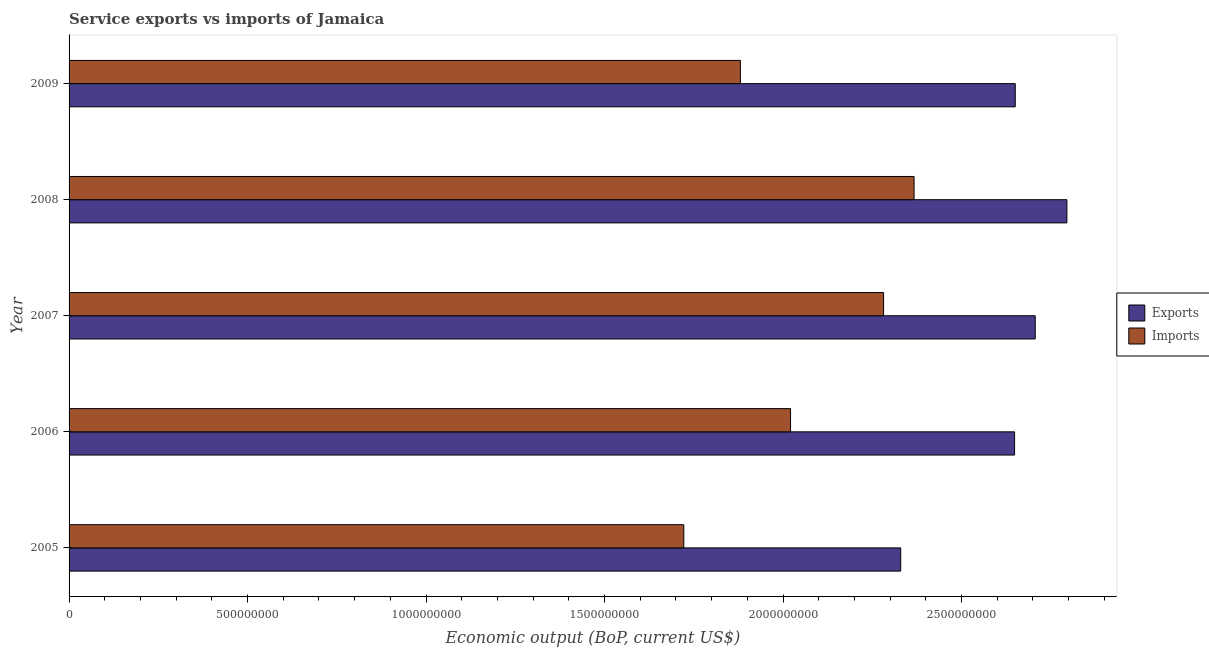How many different coloured bars are there?
Your answer should be compact. 2. Are the number of bars per tick equal to the number of legend labels?
Your answer should be compact. Yes. How many bars are there on the 4th tick from the bottom?
Keep it short and to the point. 2. What is the amount of service exports in 2008?
Provide a short and direct response. 2.80e+09. Across all years, what is the maximum amount of service exports?
Ensure brevity in your answer.  2.80e+09. Across all years, what is the minimum amount of service exports?
Your answer should be compact. 2.33e+09. What is the total amount of service imports in the graph?
Your response must be concise. 1.03e+1. What is the difference between the amount of service imports in 2006 and that in 2009?
Your answer should be very brief. 1.40e+08. What is the difference between the amount of service imports in 2008 and the amount of service exports in 2007?
Keep it short and to the point. -3.39e+08. What is the average amount of service imports per year?
Give a very brief answer. 2.05e+09. In the year 2005, what is the difference between the amount of service exports and amount of service imports?
Provide a succinct answer. 6.08e+08. In how many years, is the amount of service imports greater than 800000000 US$?
Your answer should be very brief. 5. What is the ratio of the amount of service imports in 2006 to that in 2007?
Offer a very short reply. 0.89. Is the difference between the amount of service imports in 2005 and 2008 greater than the difference between the amount of service exports in 2005 and 2008?
Make the answer very short. No. What is the difference between the highest and the second highest amount of service imports?
Ensure brevity in your answer.  8.54e+07. What is the difference between the highest and the lowest amount of service exports?
Offer a terse response. 4.66e+08. What does the 1st bar from the top in 2008 represents?
Make the answer very short. Imports. What does the 2nd bar from the bottom in 2009 represents?
Your answer should be very brief. Imports. How many bars are there?
Offer a terse response. 10. What is the difference between two consecutive major ticks on the X-axis?
Make the answer very short. 5.00e+08. Does the graph contain grids?
Make the answer very short. No. Where does the legend appear in the graph?
Give a very brief answer. Center right. How are the legend labels stacked?
Make the answer very short. Vertical. What is the title of the graph?
Provide a succinct answer. Service exports vs imports of Jamaica. Does "Number of departures" appear as one of the legend labels in the graph?
Provide a short and direct response. No. What is the label or title of the X-axis?
Provide a succinct answer. Economic output (BoP, current US$). What is the label or title of the Y-axis?
Ensure brevity in your answer.  Year. What is the Economic output (BoP, current US$) of Exports in 2005?
Offer a very short reply. 2.33e+09. What is the Economic output (BoP, current US$) in Imports in 2005?
Make the answer very short. 1.72e+09. What is the Economic output (BoP, current US$) of Exports in 2006?
Your response must be concise. 2.65e+09. What is the Economic output (BoP, current US$) of Imports in 2006?
Offer a very short reply. 2.02e+09. What is the Economic output (BoP, current US$) of Exports in 2007?
Provide a succinct answer. 2.71e+09. What is the Economic output (BoP, current US$) of Imports in 2007?
Give a very brief answer. 2.28e+09. What is the Economic output (BoP, current US$) of Exports in 2008?
Provide a succinct answer. 2.80e+09. What is the Economic output (BoP, current US$) in Imports in 2008?
Your answer should be very brief. 2.37e+09. What is the Economic output (BoP, current US$) in Exports in 2009?
Your answer should be very brief. 2.65e+09. What is the Economic output (BoP, current US$) of Imports in 2009?
Provide a short and direct response. 1.88e+09. Across all years, what is the maximum Economic output (BoP, current US$) of Exports?
Provide a short and direct response. 2.80e+09. Across all years, what is the maximum Economic output (BoP, current US$) of Imports?
Offer a terse response. 2.37e+09. Across all years, what is the minimum Economic output (BoP, current US$) in Exports?
Make the answer very short. 2.33e+09. Across all years, what is the minimum Economic output (BoP, current US$) in Imports?
Your answer should be very brief. 1.72e+09. What is the total Economic output (BoP, current US$) of Exports in the graph?
Provide a succinct answer. 1.31e+1. What is the total Economic output (BoP, current US$) in Imports in the graph?
Offer a very short reply. 1.03e+1. What is the difference between the Economic output (BoP, current US$) in Exports in 2005 and that in 2006?
Provide a succinct answer. -3.19e+08. What is the difference between the Economic output (BoP, current US$) in Imports in 2005 and that in 2006?
Your answer should be compact. -2.99e+08. What is the difference between the Economic output (BoP, current US$) in Exports in 2005 and that in 2007?
Your answer should be compact. -3.77e+08. What is the difference between the Economic output (BoP, current US$) of Imports in 2005 and that in 2007?
Ensure brevity in your answer.  -5.60e+08. What is the difference between the Economic output (BoP, current US$) of Exports in 2005 and that in 2008?
Provide a succinct answer. -4.66e+08. What is the difference between the Economic output (BoP, current US$) of Imports in 2005 and that in 2008?
Ensure brevity in your answer.  -6.45e+08. What is the difference between the Economic output (BoP, current US$) in Exports in 2005 and that in 2009?
Ensure brevity in your answer.  -3.21e+08. What is the difference between the Economic output (BoP, current US$) in Imports in 2005 and that in 2009?
Make the answer very short. -1.59e+08. What is the difference between the Economic output (BoP, current US$) of Exports in 2006 and that in 2007?
Offer a terse response. -5.79e+07. What is the difference between the Economic output (BoP, current US$) of Imports in 2006 and that in 2007?
Ensure brevity in your answer.  -2.61e+08. What is the difference between the Economic output (BoP, current US$) of Exports in 2006 and that in 2008?
Your answer should be compact. -1.47e+08. What is the difference between the Economic output (BoP, current US$) in Imports in 2006 and that in 2008?
Keep it short and to the point. -3.46e+08. What is the difference between the Economic output (BoP, current US$) in Exports in 2006 and that in 2009?
Offer a very short reply. -1.88e+06. What is the difference between the Economic output (BoP, current US$) of Imports in 2006 and that in 2009?
Your answer should be compact. 1.40e+08. What is the difference between the Economic output (BoP, current US$) of Exports in 2007 and that in 2008?
Give a very brief answer. -8.87e+07. What is the difference between the Economic output (BoP, current US$) in Imports in 2007 and that in 2008?
Provide a succinct answer. -8.54e+07. What is the difference between the Economic output (BoP, current US$) of Exports in 2007 and that in 2009?
Offer a terse response. 5.60e+07. What is the difference between the Economic output (BoP, current US$) of Imports in 2007 and that in 2009?
Provide a short and direct response. 4.01e+08. What is the difference between the Economic output (BoP, current US$) in Exports in 2008 and that in 2009?
Offer a terse response. 1.45e+08. What is the difference between the Economic output (BoP, current US$) in Imports in 2008 and that in 2009?
Keep it short and to the point. 4.86e+08. What is the difference between the Economic output (BoP, current US$) in Exports in 2005 and the Economic output (BoP, current US$) in Imports in 2006?
Your response must be concise. 3.09e+08. What is the difference between the Economic output (BoP, current US$) in Exports in 2005 and the Economic output (BoP, current US$) in Imports in 2007?
Offer a terse response. 4.80e+07. What is the difference between the Economic output (BoP, current US$) of Exports in 2005 and the Economic output (BoP, current US$) of Imports in 2008?
Your answer should be very brief. -3.74e+07. What is the difference between the Economic output (BoP, current US$) in Exports in 2005 and the Economic output (BoP, current US$) in Imports in 2009?
Offer a very short reply. 4.49e+08. What is the difference between the Economic output (BoP, current US$) in Exports in 2006 and the Economic output (BoP, current US$) in Imports in 2007?
Provide a succinct answer. 3.67e+08. What is the difference between the Economic output (BoP, current US$) of Exports in 2006 and the Economic output (BoP, current US$) of Imports in 2008?
Provide a short and direct response. 2.82e+08. What is the difference between the Economic output (BoP, current US$) of Exports in 2006 and the Economic output (BoP, current US$) of Imports in 2009?
Your answer should be compact. 7.68e+08. What is the difference between the Economic output (BoP, current US$) of Exports in 2007 and the Economic output (BoP, current US$) of Imports in 2008?
Provide a short and direct response. 3.39e+08. What is the difference between the Economic output (BoP, current US$) of Exports in 2007 and the Economic output (BoP, current US$) of Imports in 2009?
Ensure brevity in your answer.  8.26e+08. What is the difference between the Economic output (BoP, current US$) in Exports in 2008 and the Economic output (BoP, current US$) in Imports in 2009?
Give a very brief answer. 9.15e+08. What is the average Economic output (BoP, current US$) in Exports per year?
Give a very brief answer. 2.63e+09. What is the average Economic output (BoP, current US$) of Imports per year?
Provide a succinct answer. 2.05e+09. In the year 2005, what is the difference between the Economic output (BoP, current US$) in Exports and Economic output (BoP, current US$) in Imports?
Keep it short and to the point. 6.08e+08. In the year 2006, what is the difference between the Economic output (BoP, current US$) in Exports and Economic output (BoP, current US$) in Imports?
Keep it short and to the point. 6.28e+08. In the year 2007, what is the difference between the Economic output (BoP, current US$) in Exports and Economic output (BoP, current US$) in Imports?
Ensure brevity in your answer.  4.25e+08. In the year 2008, what is the difference between the Economic output (BoP, current US$) in Exports and Economic output (BoP, current US$) in Imports?
Give a very brief answer. 4.28e+08. In the year 2009, what is the difference between the Economic output (BoP, current US$) in Exports and Economic output (BoP, current US$) in Imports?
Offer a very short reply. 7.70e+08. What is the ratio of the Economic output (BoP, current US$) of Exports in 2005 to that in 2006?
Your response must be concise. 0.88. What is the ratio of the Economic output (BoP, current US$) in Imports in 2005 to that in 2006?
Provide a succinct answer. 0.85. What is the ratio of the Economic output (BoP, current US$) in Exports in 2005 to that in 2007?
Make the answer very short. 0.86. What is the ratio of the Economic output (BoP, current US$) in Imports in 2005 to that in 2007?
Your response must be concise. 0.75. What is the ratio of the Economic output (BoP, current US$) in Exports in 2005 to that in 2008?
Give a very brief answer. 0.83. What is the ratio of the Economic output (BoP, current US$) in Imports in 2005 to that in 2008?
Provide a succinct answer. 0.73. What is the ratio of the Economic output (BoP, current US$) in Exports in 2005 to that in 2009?
Provide a short and direct response. 0.88. What is the ratio of the Economic output (BoP, current US$) of Imports in 2005 to that in 2009?
Give a very brief answer. 0.92. What is the ratio of the Economic output (BoP, current US$) of Exports in 2006 to that in 2007?
Your answer should be compact. 0.98. What is the ratio of the Economic output (BoP, current US$) of Imports in 2006 to that in 2007?
Provide a succinct answer. 0.89. What is the ratio of the Economic output (BoP, current US$) in Exports in 2006 to that in 2008?
Give a very brief answer. 0.95. What is the ratio of the Economic output (BoP, current US$) in Imports in 2006 to that in 2008?
Your answer should be very brief. 0.85. What is the ratio of the Economic output (BoP, current US$) in Imports in 2006 to that in 2009?
Offer a very short reply. 1.07. What is the ratio of the Economic output (BoP, current US$) in Exports in 2007 to that in 2008?
Offer a terse response. 0.97. What is the ratio of the Economic output (BoP, current US$) of Imports in 2007 to that in 2008?
Your answer should be very brief. 0.96. What is the ratio of the Economic output (BoP, current US$) in Exports in 2007 to that in 2009?
Your answer should be very brief. 1.02. What is the ratio of the Economic output (BoP, current US$) of Imports in 2007 to that in 2009?
Make the answer very short. 1.21. What is the ratio of the Economic output (BoP, current US$) of Exports in 2008 to that in 2009?
Make the answer very short. 1.05. What is the ratio of the Economic output (BoP, current US$) of Imports in 2008 to that in 2009?
Give a very brief answer. 1.26. What is the difference between the highest and the second highest Economic output (BoP, current US$) of Exports?
Give a very brief answer. 8.87e+07. What is the difference between the highest and the second highest Economic output (BoP, current US$) in Imports?
Offer a terse response. 8.54e+07. What is the difference between the highest and the lowest Economic output (BoP, current US$) in Exports?
Give a very brief answer. 4.66e+08. What is the difference between the highest and the lowest Economic output (BoP, current US$) of Imports?
Make the answer very short. 6.45e+08. 